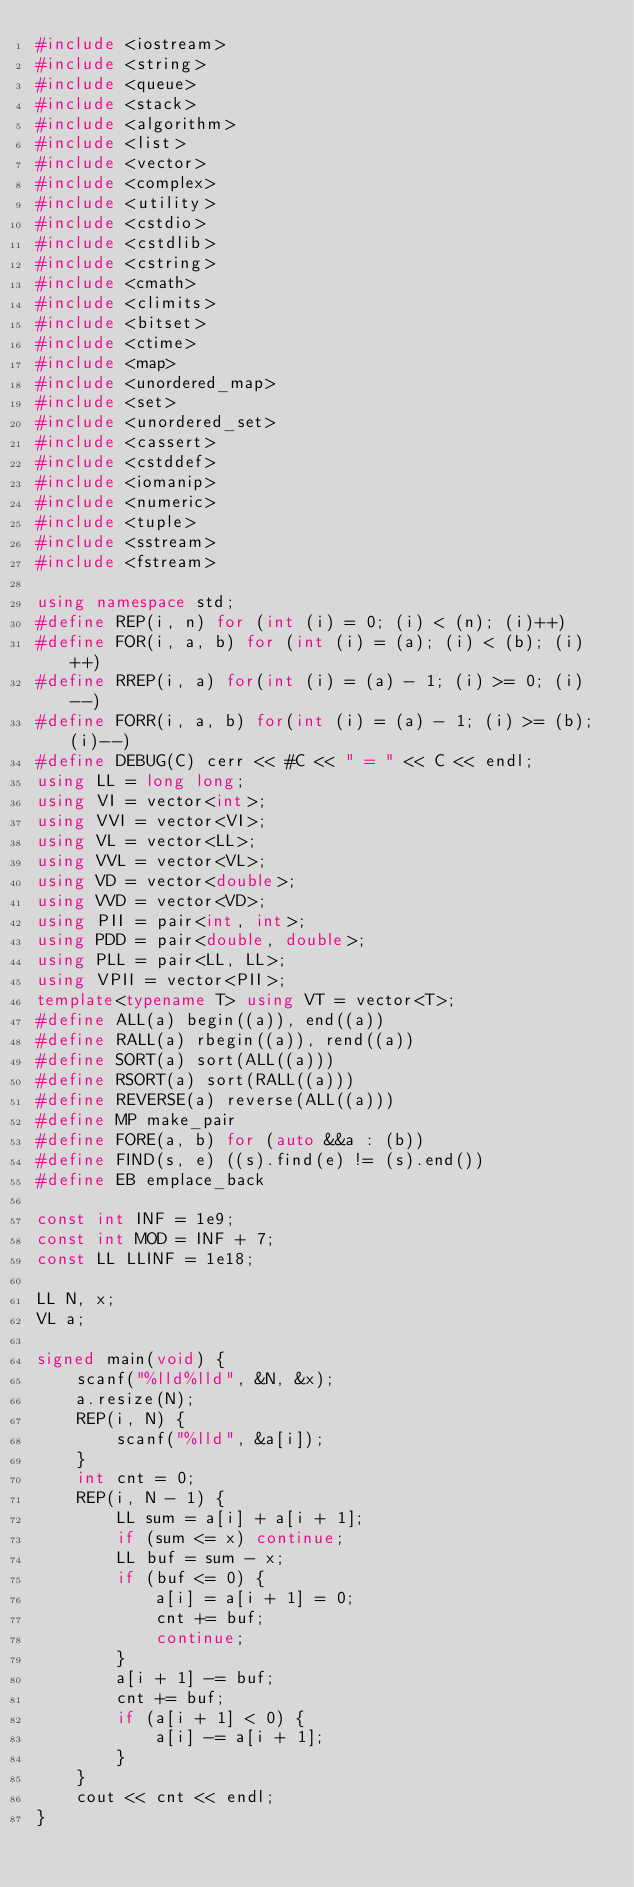Convert code to text. <code><loc_0><loc_0><loc_500><loc_500><_C++_>#include <iostream>
#include <string>
#include <queue>
#include <stack>
#include <algorithm>
#include <list>
#include <vector>
#include <complex>
#include <utility>
#include <cstdio>
#include <cstdlib>
#include <cstring>
#include <cmath>
#include <climits>
#include <bitset>
#include <ctime>
#include <map>
#include <unordered_map>
#include <set>
#include <unordered_set>
#include <cassert>
#include <cstddef>
#include <iomanip>
#include <numeric>
#include <tuple>
#include <sstream>
#include <fstream>

using namespace std;
#define REP(i, n) for (int (i) = 0; (i) < (n); (i)++)
#define FOR(i, a, b) for (int (i) = (a); (i) < (b); (i)++)
#define RREP(i, a) for(int (i) = (a) - 1; (i) >= 0; (i)--)
#define FORR(i, a, b) for(int (i) = (a) - 1; (i) >= (b); (i)--)
#define DEBUG(C) cerr << #C << " = " << C << endl;
using LL = long long;
using VI = vector<int>;
using VVI = vector<VI>;
using VL = vector<LL>;
using VVL = vector<VL>;
using VD = vector<double>;
using VVD = vector<VD>;
using PII = pair<int, int>;
using PDD = pair<double, double>;
using PLL = pair<LL, LL>;
using VPII = vector<PII>;
template<typename T> using VT = vector<T>;
#define ALL(a) begin((a)), end((a))
#define RALL(a) rbegin((a)), rend((a))
#define SORT(a) sort(ALL((a)))
#define RSORT(a) sort(RALL((a)))
#define REVERSE(a) reverse(ALL((a)))
#define MP make_pair
#define FORE(a, b) for (auto &&a : (b))
#define FIND(s, e) ((s).find(e) != (s).end())
#define EB emplace_back

const int INF = 1e9;
const int MOD = INF + 7;
const LL LLINF = 1e18;

LL N, x;
VL a;

signed main(void) {
    scanf("%lld%lld", &N, &x);
    a.resize(N);
    REP(i, N) {
        scanf("%lld", &a[i]);
    }
    int cnt = 0;
    REP(i, N - 1) {
        LL sum = a[i] + a[i + 1];
        if (sum <= x) continue;
        LL buf = sum - x;
        if (buf <= 0) {
            a[i] = a[i + 1] = 0;
            cnt += buf;
            continue;
        }
        a[i + 1] -= buf;
        cnt += buf;
        if (a[i + 1] < 0) {
            a[i] -= a[i + 1];
        }
    }
    cout << cnt << endl;
}
</code> 